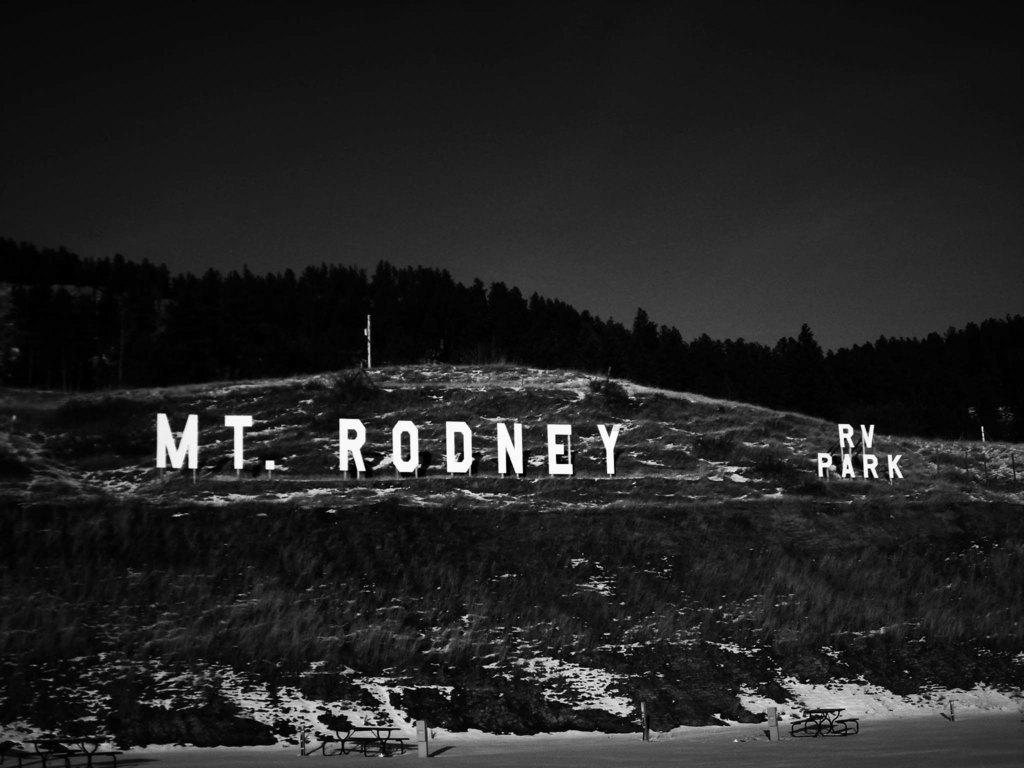<image>
Summarize the visual content of the image. A sign that reads "MT. RODNEY RV PARK" is standing on a hillside. 